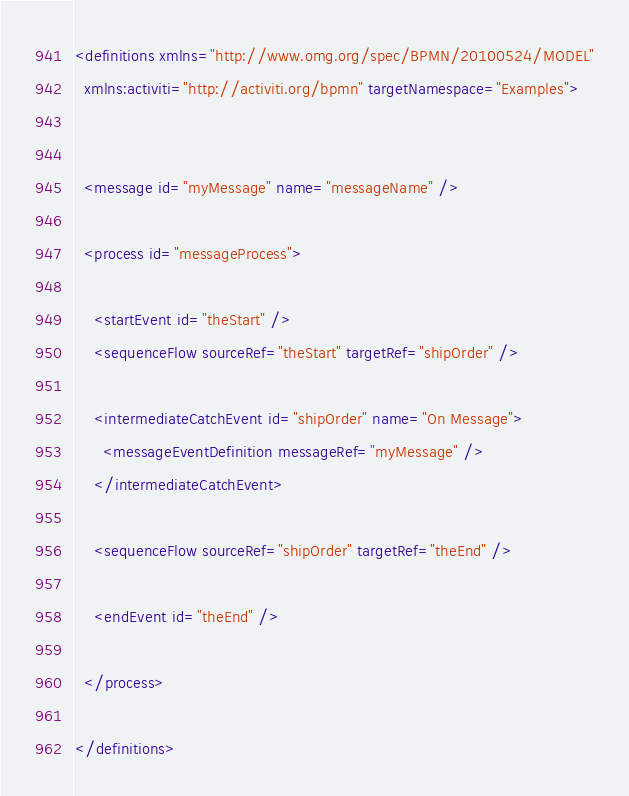Convert code to text. <code><loc_0><loc_0><loc_500><loc_500><_XML_><definitions xmlns="http://www.omg.org/spec/BPMN/20100524/MODEL"
  xmlns:activiti="http://activiti.org/bpmn" targetNamespace="Examples">


  <message id="myMessage" name="messageName" />

  <process id="messageProcess">

    <startEvent id="theStart" />
    <sequenceFlow sourceRef="theStart" targetRef="shipOrder" />

    <intermediateCatchEvent id="shipOrder" name="On Message">
      <messageEventDefinition messageRef="myMessage" />
    </intermediateCatchEvent>

    <sequenceFlow sourceRef="shipOrder" targetRef="theEnd" />

    <endEvent id="theEnd" />

  </process>

</definitions>
</code> 